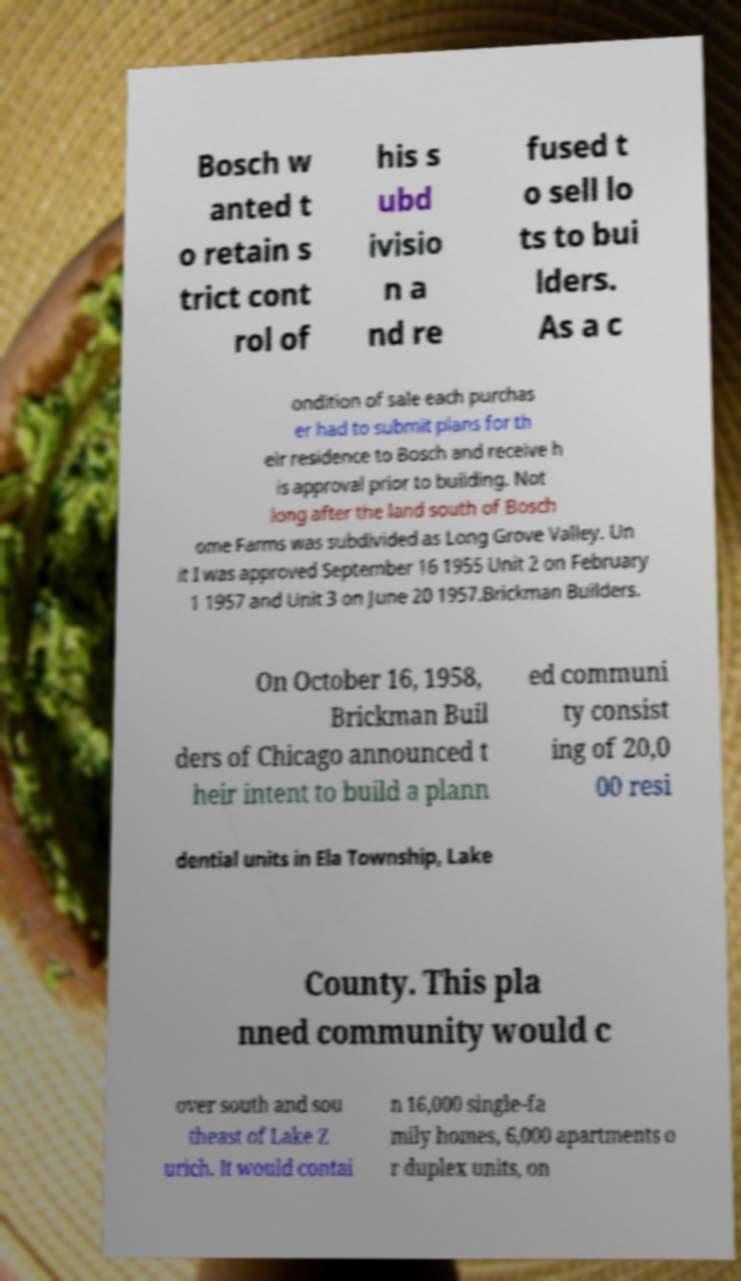Can you accurately transcribe the text from the provided image for me? Bosch w anted t o retain s trict cont rol of his s ubd ivisio n a nd re fused t o sell lo ts to bui lders. As a c ondition of sale each purchas er had to submit plans for th eir residence to Bosch and receive h is approval prior to building. Not long after the land south of Bosch ome Farms was subdivided as Long Grove Valley. Un it I was approved September 16 1955 Unit 2 on February 1 1957 and Unit 3 on June 20 1957.Brickman Builders. On October 16, 1958, Brickman Buil ders of Chicago announced t heir intent to build a plann ed communi ty consist ing of 20,0 00 resi dential units in Ela Township, Lake County. This pla nned community would c over south and sou theast of Lake Z urich. It would contai n 16,000 single-fa mily homes, 6,000 apartments o r duplex units, on 